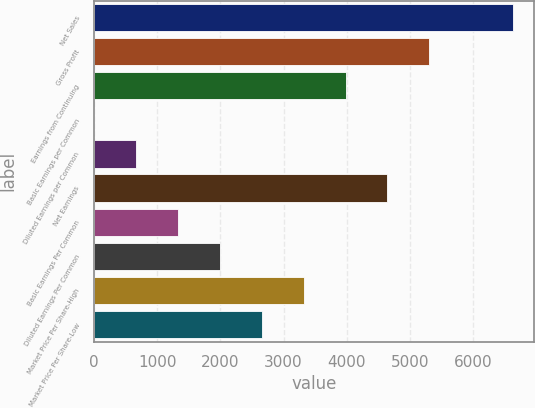<chart> <loc_0><loc_0><loc_500><loc_500><bar_chart><fcel>Net Sales<fcel>Gross Profit<fcel>Earnings from Continuing<fcel>Basic Earnings per Common<fcel>Diluted Earnings per Common<fcel>Net Earnings<fcel>Basic Earnings Per Common<fcel>Diluted Earnings Per Common<fcel>Market Price Per Share-High<fcel>Market Price Per Share-Low<nl><fcel>6637<fcel>5309.66<fcel>3982.28<fcel>0.15<fcel>663.84<fcel>4645.97<fcel>1327.53<fcel>1991.22<fcel>3318.59<fcel>2654.91<nl></chart> 